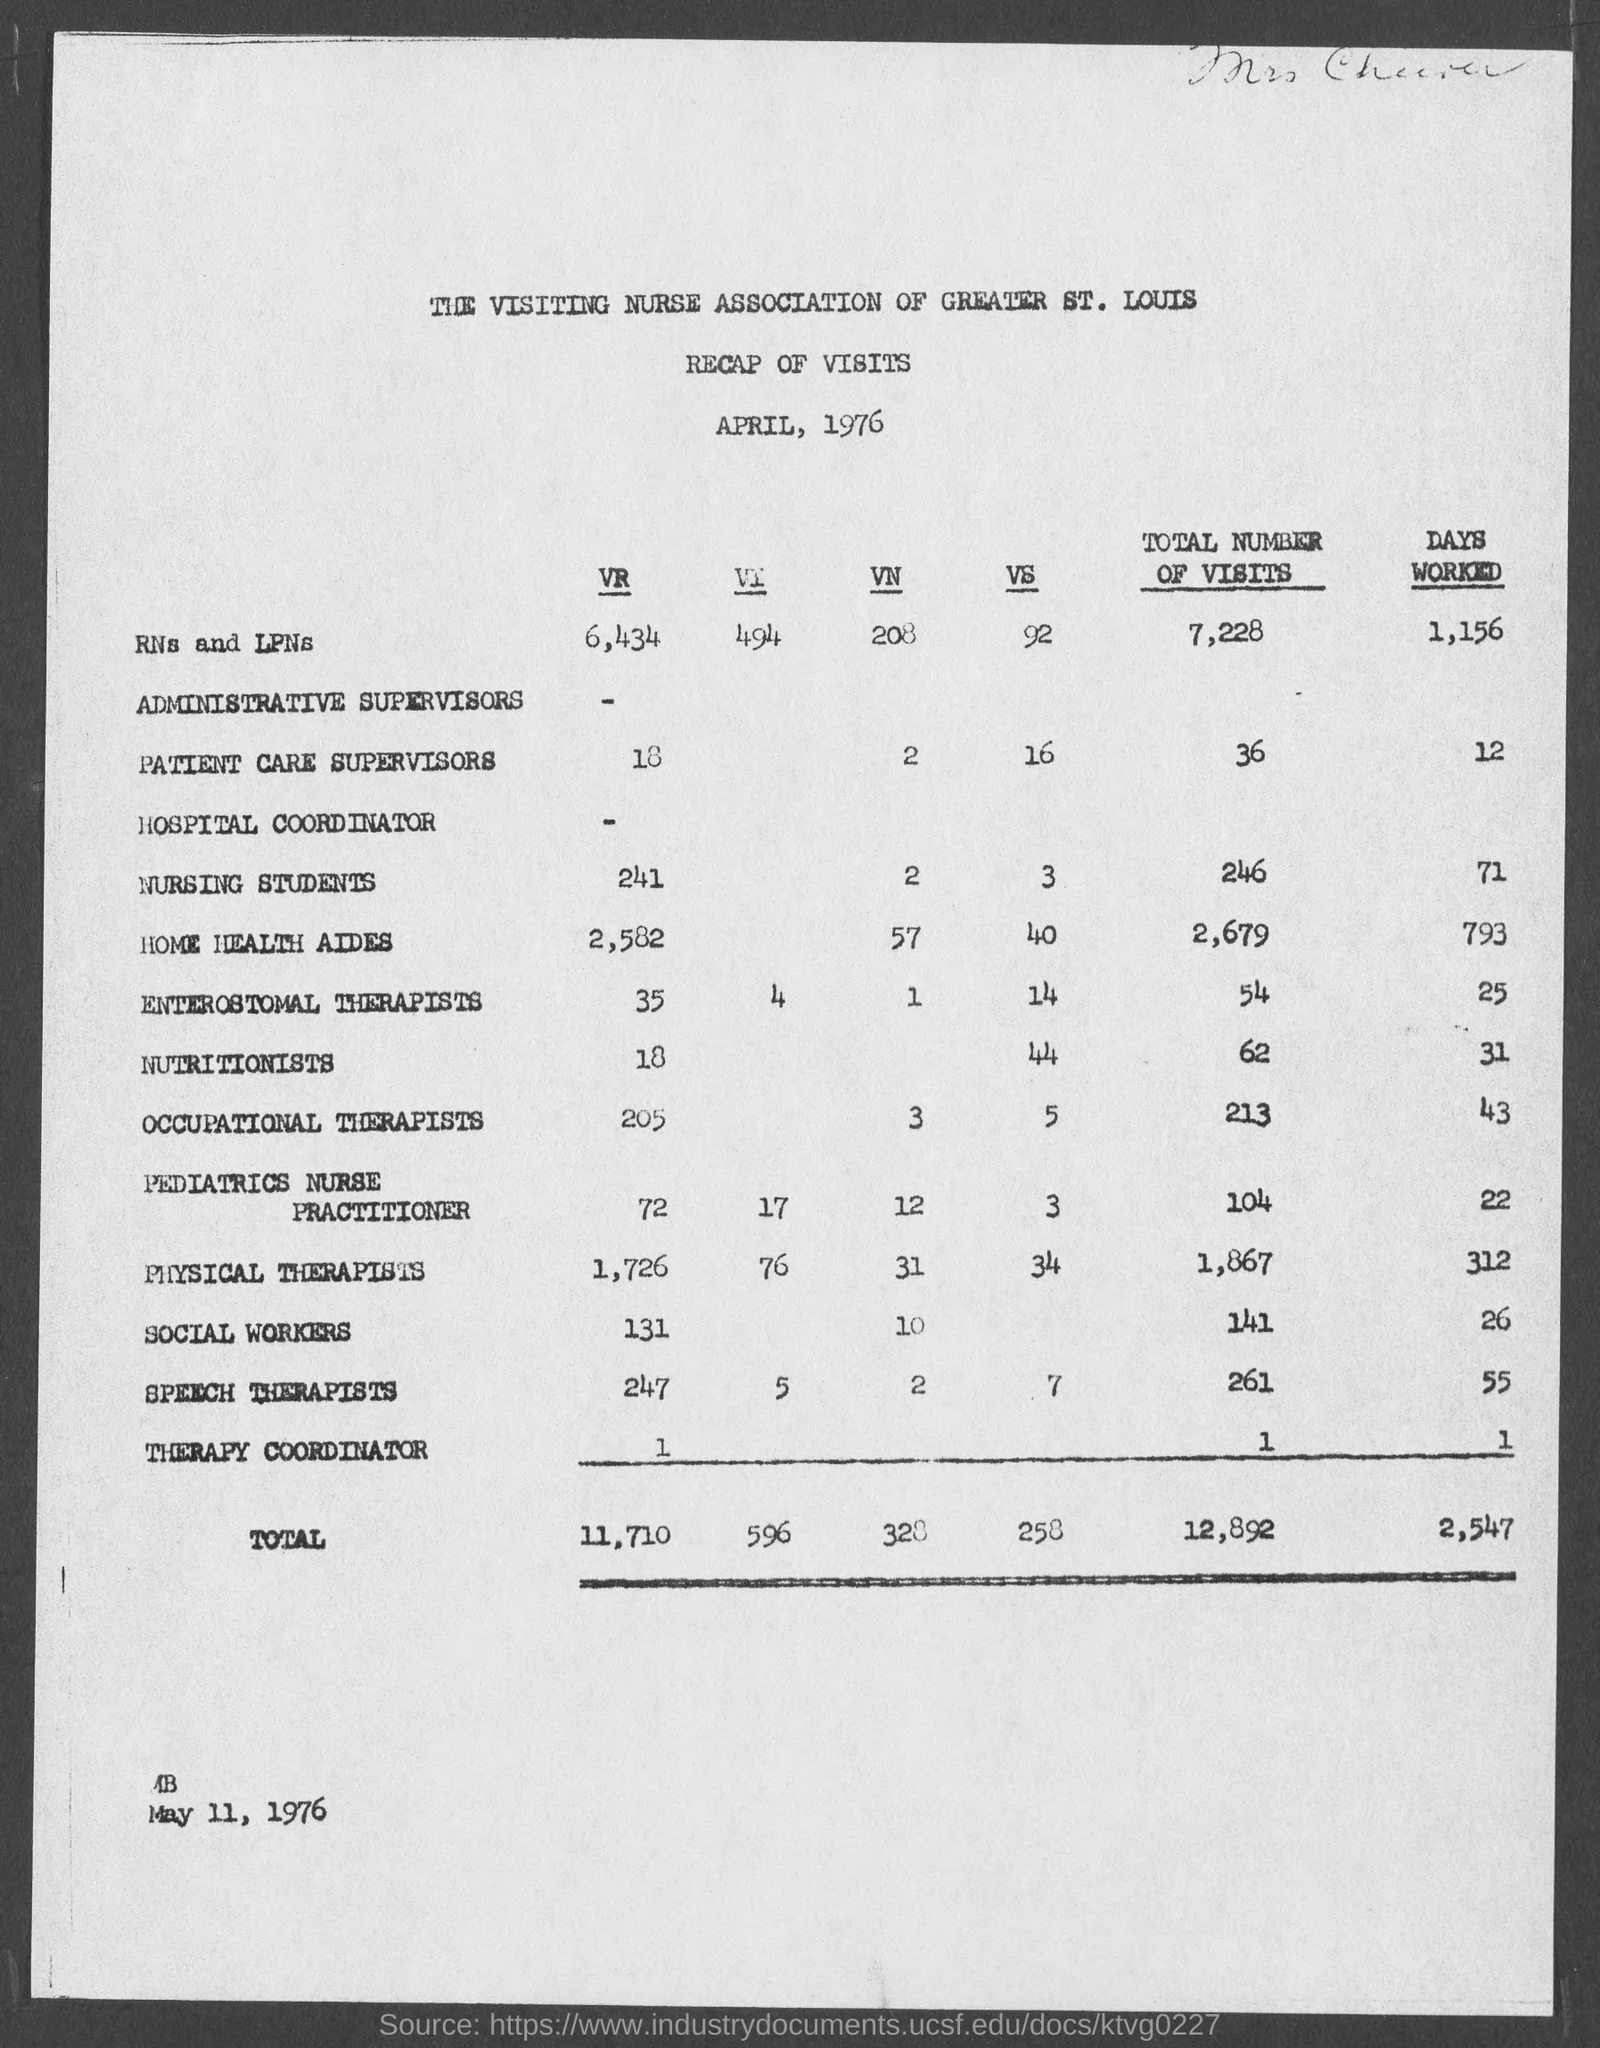Identify some key points in this picture. The document provides the number of days worked by RNs and LPNs as 1,156. The document provides a total of 246 visits by nursing students. The number of days worked by nutritionists, as stated in the document, is 31. The document provides a total of 261 visits by speech therapists. The document lists the number of days worked by occupational therapists as 43 days. 